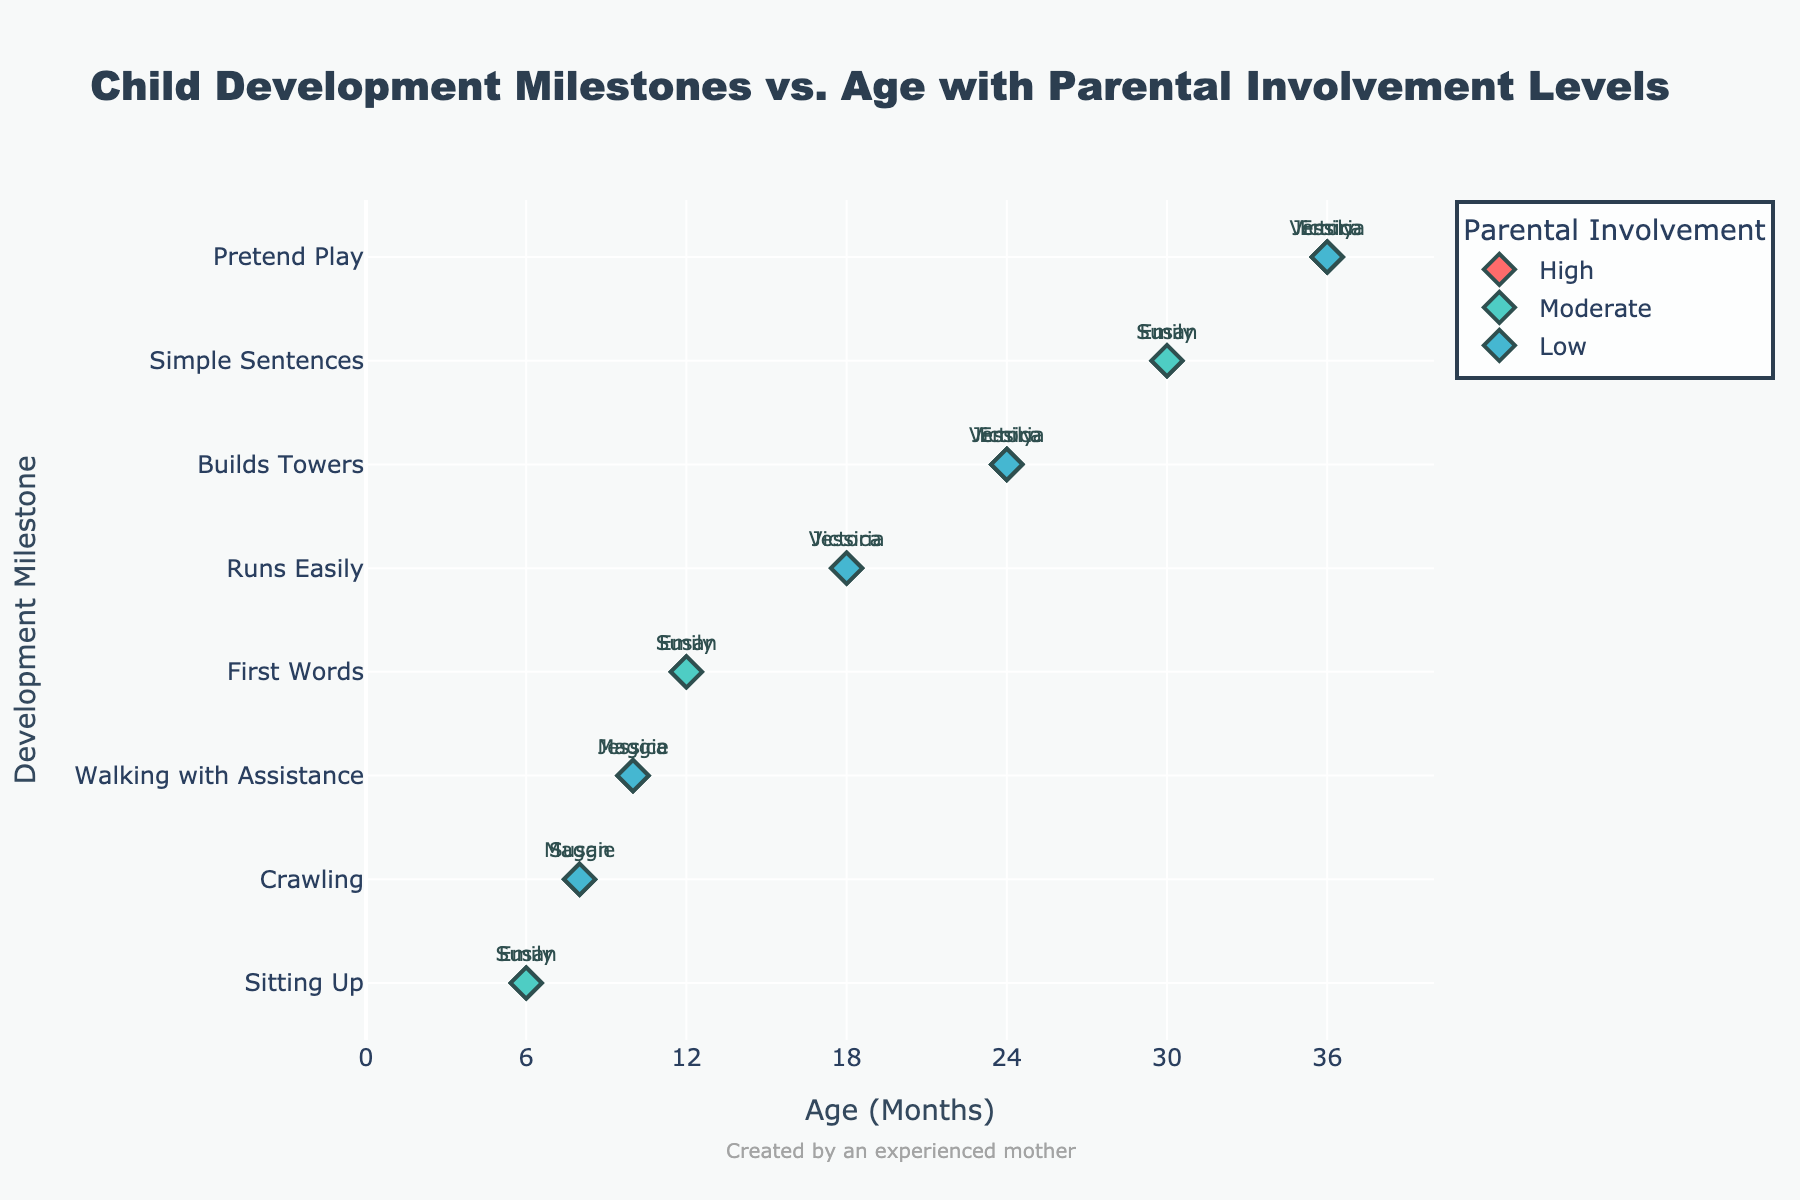What's the title of the figure? The title of the figure is shown at the top of the plot. It reads "Child Development Milestones vs. Age with Parental Involvement Levels".
Answer: Child Development Milestones vs. Age with Parental Involvement Levels Which milestone has children at the youngest age? Since the x-axis represents age in months and the y-axis represents milestones, the milestone at the youngest age is "Sitting Up" at 6 months.
Answer: Sitting Up How many children at 24 months have achieved the milestone "Builds Towers"? By finding the x-axis value of 24 months and checking the corresponding y-axis milestone "Builds Towers", we see three data points.
Answer: 3 Which parental involvement level has the highest number of milestones achieved by children? By counting the number of markers of each color, High level (red) appears the most frequently.
Answer: High Which children have the milestone "Pretend Play" at 36 months and what are their parental involvement levels? At 36 months on the x-axis, the y-axis milestone is "Pretend Play". The parents involved are Jessica (High), Emily (Moderate), and Victoria (Low).
Answer: Jessica (High), Emily (Moderate), Victoria (Low) At what ages does Susan's child achieve milestones? All markers labeled "Susan" need to be identified, those appear at ages 6, 8, 12, and 30 months.
Answer: 6, 8, 12, 30 What is the range of ages where children achieve their first words? The milestone "First Words" on the y-axis is matched to the x-axis ages, which are 12 months for Susan and Emily.
Answer: 12 months Compare the milestones at 18 months and 30 months. What are they and who achieved them? At 18 months, the milestone is "Runs Easily" achieved by Jessica (High) and Victoria (Low); at 30 months, it's "Simple Sentences" achieved by Susan (High) and Emily (Moderate).
Answer: Runs Easily: Jessica (High), Victoria (Low); Simple Sentences: Susan (High), Emily (Moderate) How many milestones are achieved with Moderate parental involvement? Count all the markers associated with the Moderate color, found on different y-axis milestones, counting up to six.
Answer: 6 